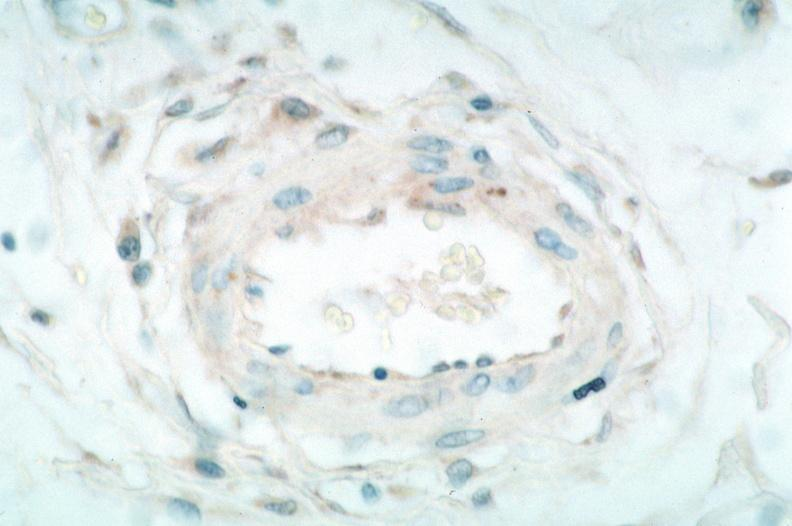what is vasculitis , rocky mountain spotted?
Answer the question using a single word or phrase. Fever immunoperoxidase staining vessels for rickettsia rickettsii 